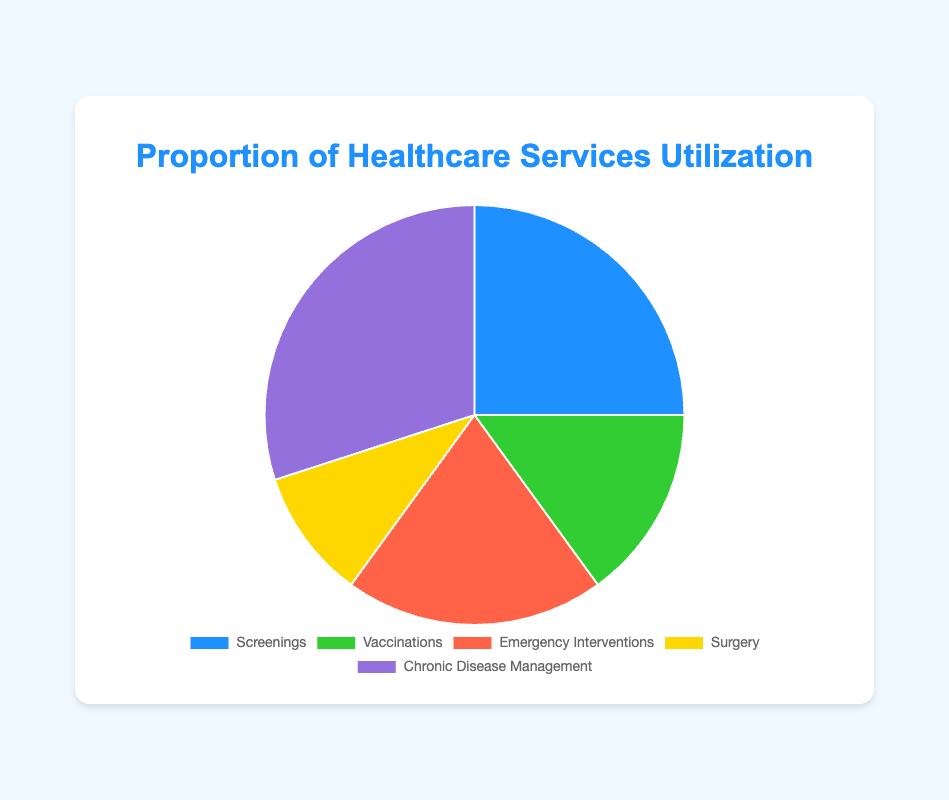What percentage of healthcare services utilization is taken up by preventative services (Screenings and Vaccinations)? Add the percentages of Screenings and Vaccinations: 25% + 15% = 40%
Answer: 40% Which type of healthcare service has the highest utilization? Identify the service with the highest percentage. Chronic Disease Management is 30%, which is the highest.
Answer: Chronic Disease Management How does the utilization of Emergency Interventions compare to Screenings? Compare the percentages of Emergency Interventions (20%) and Screenings (25%). Screenings have 5% more utilization than Emergency Interventions.
Answer: Screenings have 5% more utilization What is the total proportion of reactive healthcare services (Emergency Interventions, Surgery, Chronic Disease Management)? Add the percentages of Emergency Interventions, Surgery, and Chronic Disease Management: 20% + 10% + 30% = 60%
Answer: 60% How many times greater is the utilization of Chronic Disease Management compared to Surgery? Divide the percentage of Chronic Disease Management (30%) by the percentage of Surgery (10%): 30 / 10 = 3
Answer: 3 times What are the two least utilized healthcare services, and what are their respective proportions? Identify the two services with the smallest percentages. Surgery (10%) and Vaccinations (15%) are the least utilized.
Answer: Surgery (10%) and Vaccinations (15%) By what percentage does Chronic Disease Management exceed Vaccinations? Subtract the percentage of Vaccinations from Chronic Disease Management: 30% - 15% = 15%
Answer: 15% What is the proportion difference between the most and least utilized services? Subtract the percentage of the least utilized service (Surgery, 10%) from the most utilized service (Chronic Disease Management, 30%): 30% - 10% = 20%
Answer: 20% What is the average utilization percentage of all listed healthcare services? Sum all percentages and divide by the number of services: (25 + 15 + 20 + 10 + 30) / 5 = 20%
Answer: 20% Which healthcare service category is represented by the green color in the pie chart? The green color corresponds to Vaccinations which has a 15% utilization.
Answer: Vaccinations 